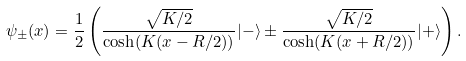<formula> <loc_0><loc_0><loc_500><loc_500>\psi _ { \pm } ( x ) = \frac { 1 } { 2 } \left ( \frac { \sqrt { K / 2 } } { \cosh ( K ( x - R / 2 ) ) } | - \rangle \pm \frac { \sqrt { K / 2 } } { \cosh ( K ( x + R / 2 ) ) } | + \rangle \right ) .</formula> 